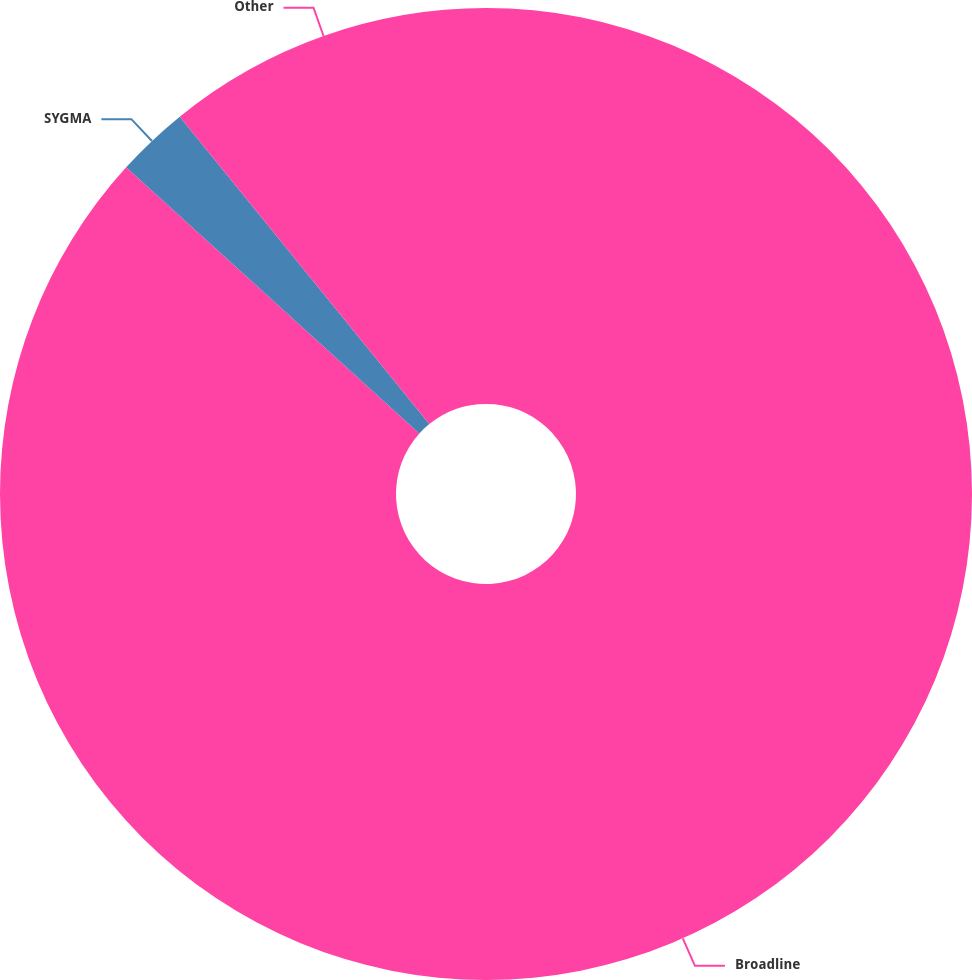Convert chart to OTSL. <chart><loc_0><loc_0><loc_500><loc_500><pie_chart><fcel>Broadline<fcel>SYGMA<fcel>Other<nl><fcel>86.73%<fcel>2.42%<fcel>10.85%<nl></chart> 